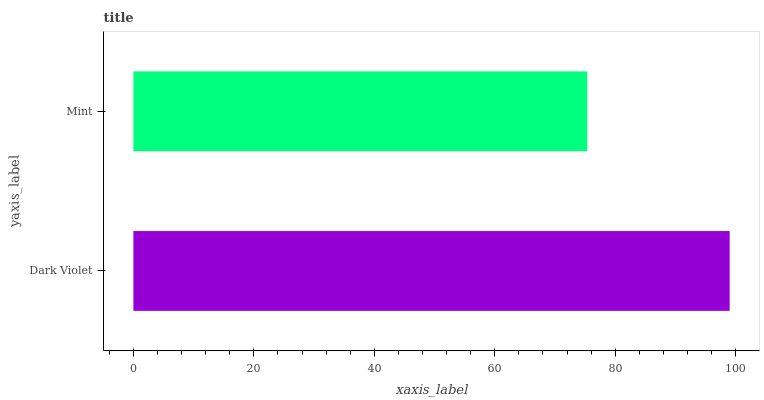Is Mint the minimum?
Answer yes or no. Yes. Is Dark Violet the maximum?
Answer yes or no. Yes. Is Mint the maximum?
Answer yes or no. No. Is Dark Violet greater than Mint?
Answer yes or no. Yes. Is Mint less than Dark Violet?
Answer yes or no. Yes. Is Mint greater than Dark Violet?
Answer yes or no. No. Is Dark Violet less than Mint?
Answer yes or no. No. Is Dark Violet the high median?
Answer yes or no. Yes. Is Mint the low median?
Answer yes or no. Yes. Is Mint the high median?
Answer yes or no. No. Is Dark Violet the low median?
Answer yes or no. No. 